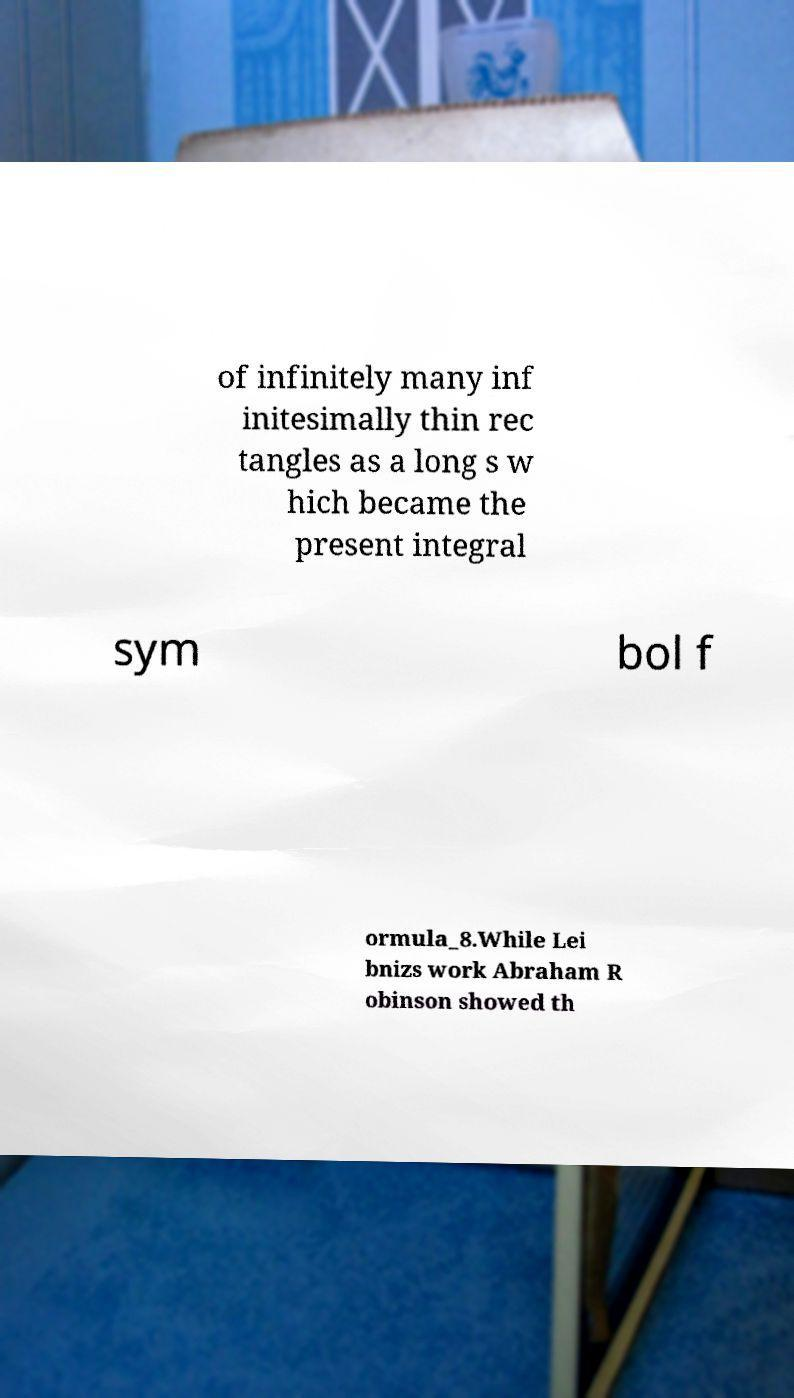What messages or text are displayed in this image? I need them in a readable, typed format. of infinitely many inf initesimally thin rec tangles as a long s w hich became the present integral sym bol f ormula_8.While Lei bnizs work Abraham R obinson showed th 